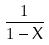<formula> <loc_0><loc_0><loc_500><loc_500>\frac { 1 } { 1 - X }</formula> 